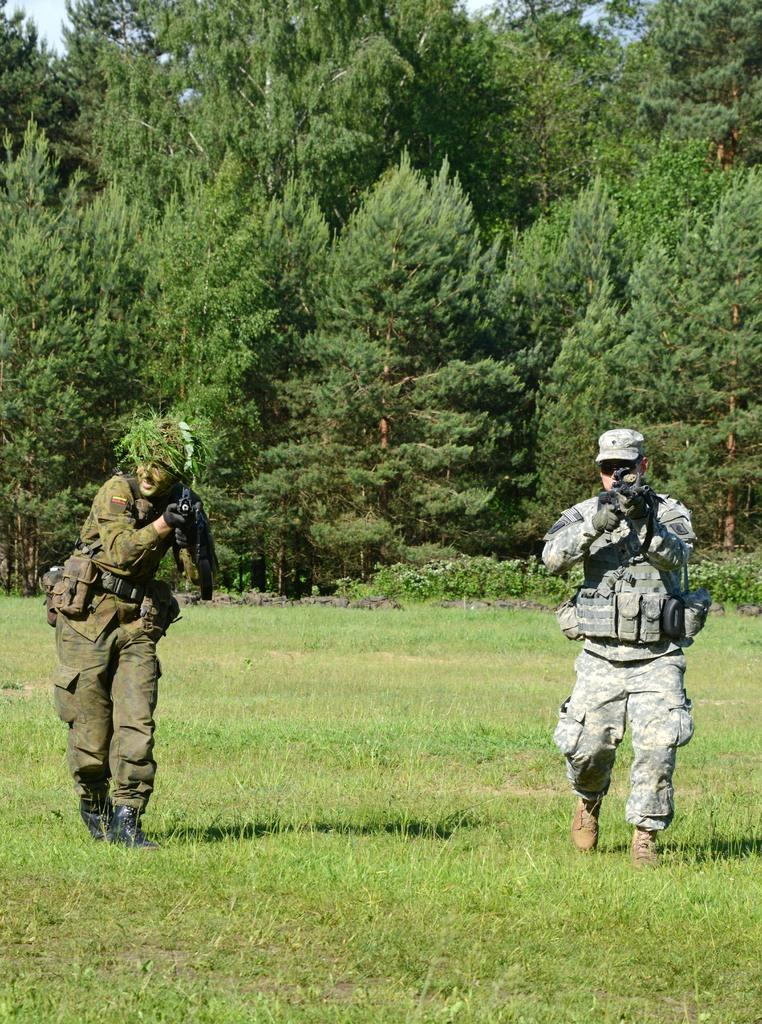What are the two persons in the image holding? The two persons in the image are holding guns. Where are the guns located in the image? The guns are visible in the background. What type of natural environment is present in the image? There are trees on the ground in the image. What is visible at the top of the image? The sky is visible at the top of the image. Can you tell me how many breaths the bat takes in the image? There is no bat present in the image, so it is not possible to determine the number of breaths it takes. 